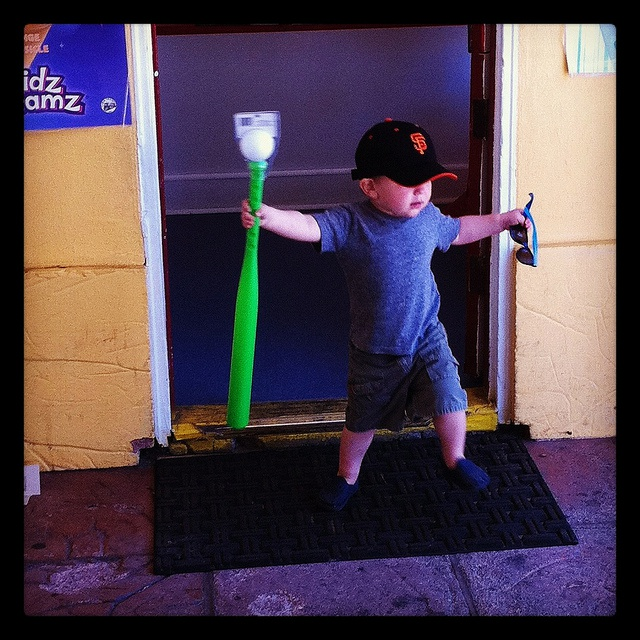Describe the objects in this image and their specific colors. I can see people in black, navy, blue, and darkblue tones, baseball bat in black, green, lightgreen, and lightgray tones, and sports ball in black, lightgray, lavender, and gray tones in this image. 